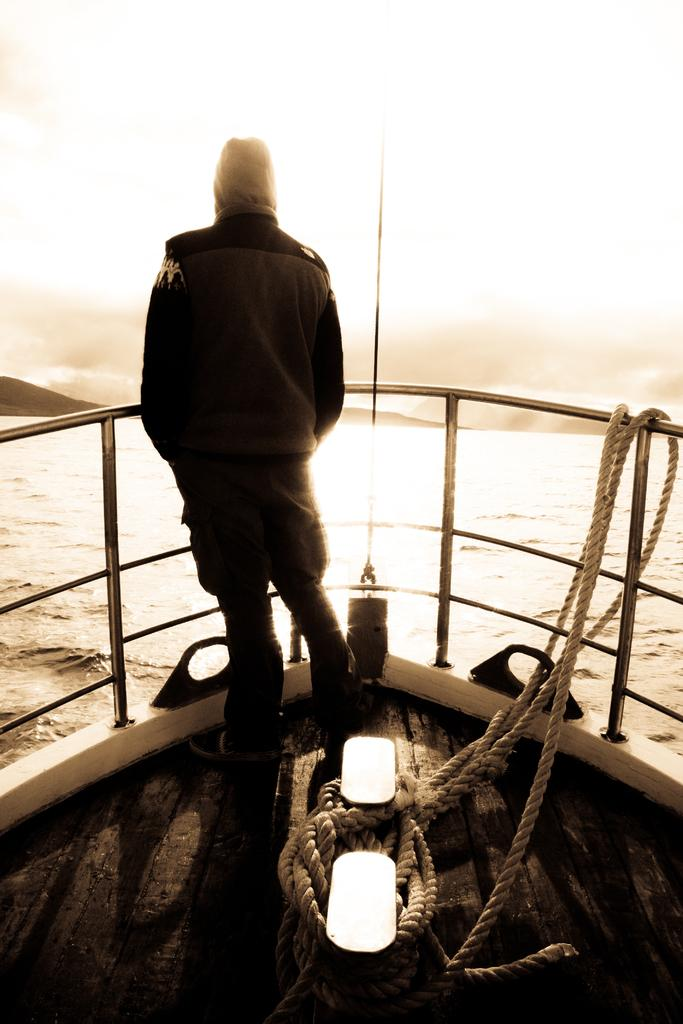What is the primary element in the image? There is water in the image. What can be seen in the background of the image? There is sky visible in the image. What is the person in the image doing? There is a person standing in a boat in the image. What object is present in the image that might be used for anchoring or pulling? There is a rope in the image. How many light sources are visible in the image? There are two lights in the image. What type of trick does the person in the boat perform with the bit in the image? There is no bit present in the image, and the person in the boat is not performing any tricks. 